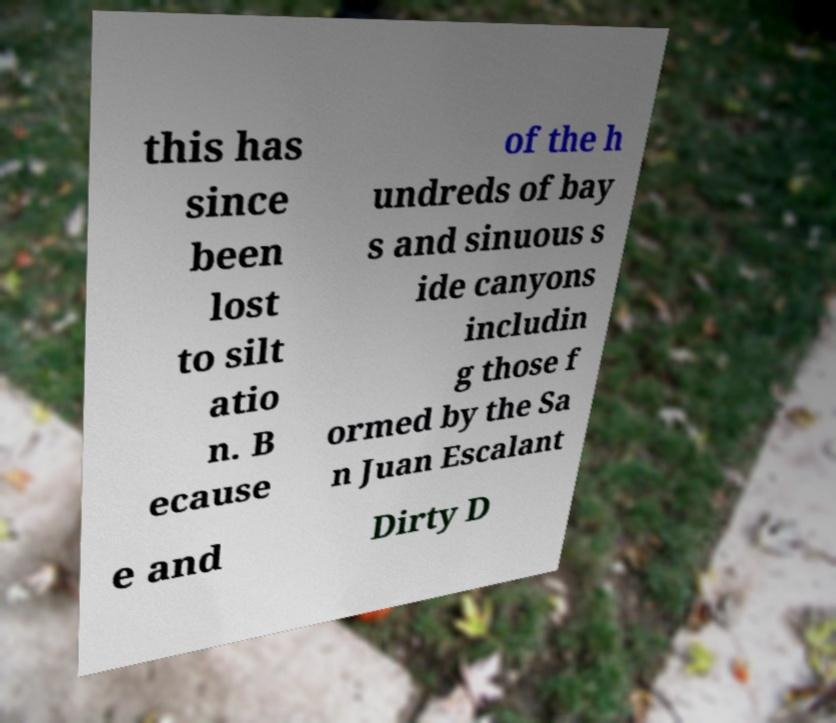For documentation purposes, I need the text within this image transcribed. Could you provide that? this has since been lost to silt atio n. B ecause of the h undreds of bay s and sinuous s ide canyons includin g those f ormed by the Sa n Juan Escalant e and Dirty D 